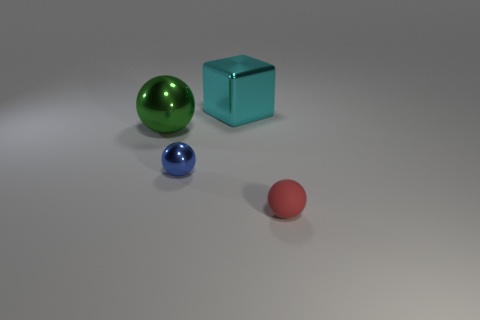Is there any other thing that has the same material as the small red ball?
Provide a short and direct response. No. There is a green sphere that is the same material as the cyan block; what is its size?
Offer a very short reply. Large. There is a small thing that is behind the small rubber object; how many blue shiny spheres are behind it?
Your answer should be very brief. 0. How many tiny red rubber balls are to the left of the matte sphere?
Offer a terse response. 0. There is a ball in front of the tiny thing that is behind the tiny sphere on the right side of the blue metal object; what is its color?
Offer a terse response. Red. There is a big shiny object that is in front of the metal cube; is it the same color as the small sphere that is left of the small red rubber thing?
Offer a terse response. No. What is the shape of the big thing that is right of the big thing to the left of the small metallic thing?
Provide a short and direct response. Cube. Is there a green metallic cube that has the same size as the blue ball?
Give a very brief answer. No. How many tiny metal objects have the same shape as the red rubber thing?
Offer a very short reply. 1. Are there an equal number of large green metallic things on the right side of the blue metallic object and rubber balls to the right of the tiny red matte thing?
Your answer should be compact. Yes. 